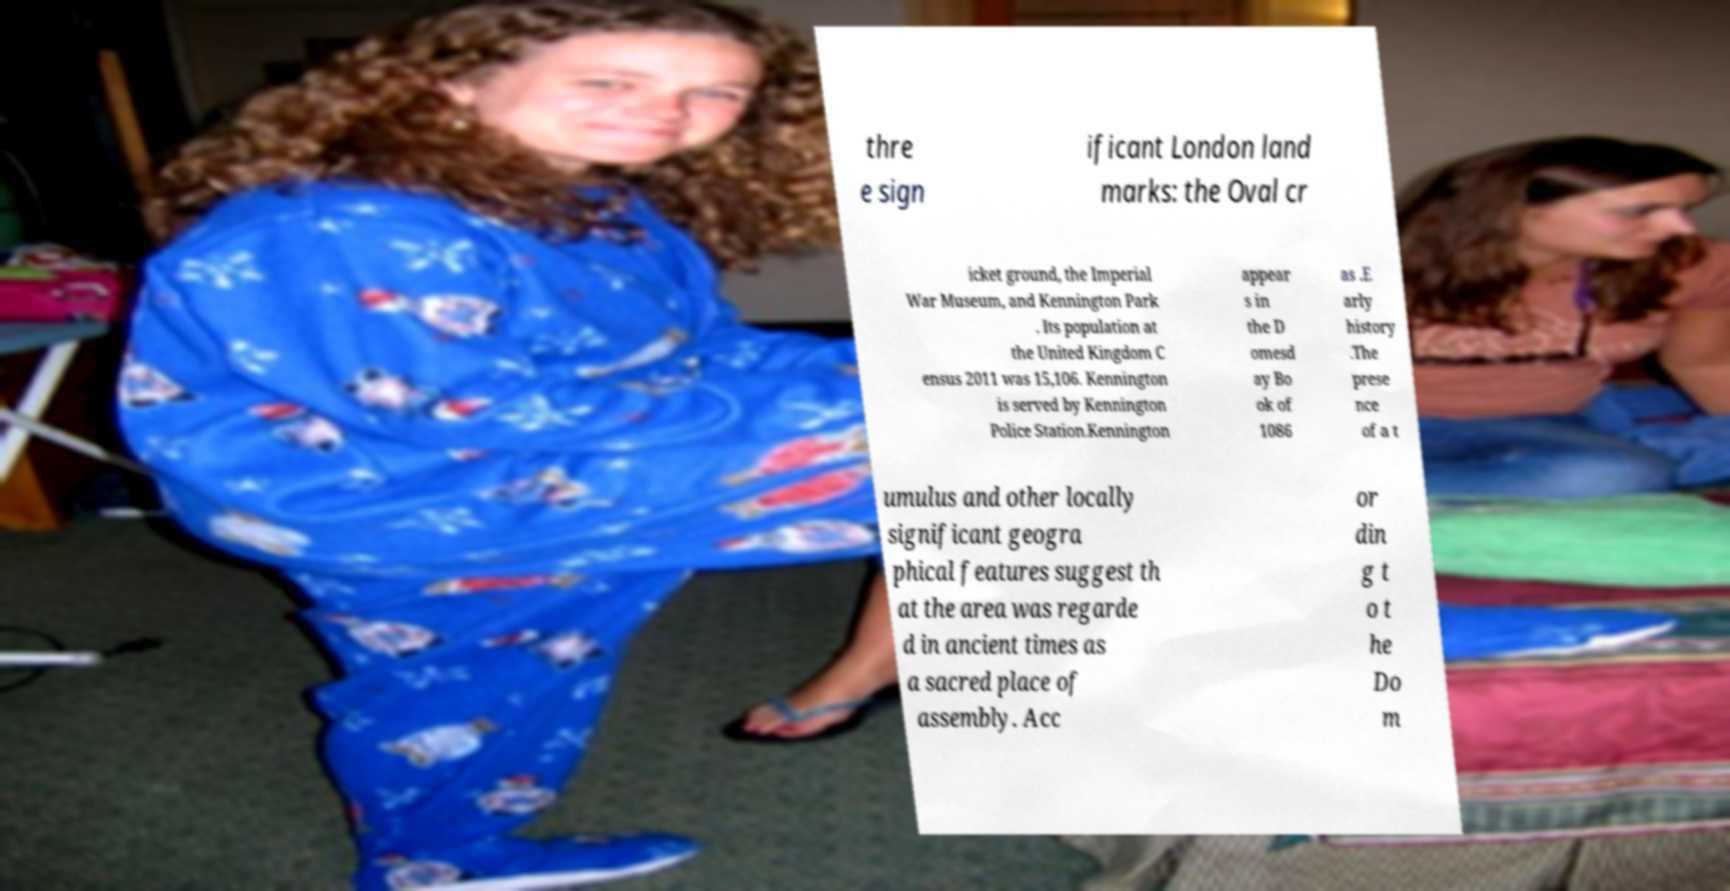Please identify and transcribe the text found in this image. thre e sign ificant London land marks: the Oval cr icket ground, the Imperial War Museum, and Kennington Park . Its population at the United Kingdom C ensus 2011 was 15,106. Kennington is served by Kennington Police Station.Kennington appear s in the D omesd ay Bo ok of 1086 as .E arly history .The prese nce of a t umulus and other locally significant geogra phical features suggest th at the area was regarde d in ancient times as a sacred place of assembly. Acc or din g t o t he Do m 